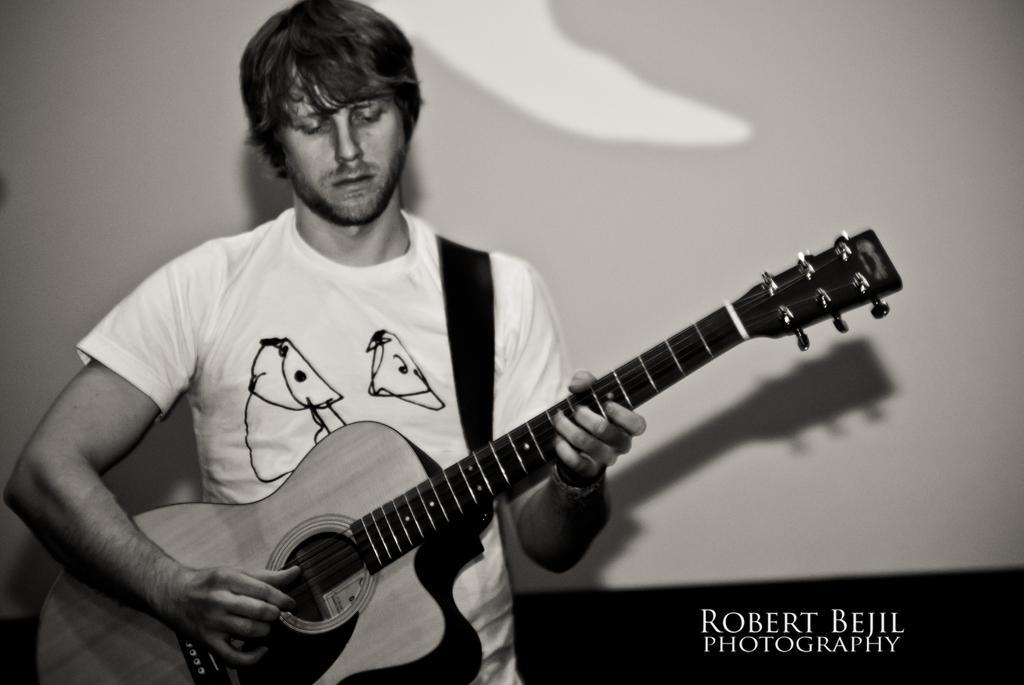Can you describe this image briefly? In this image we can see a man holding a guitar in his hands and playing it. 